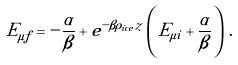Convert formula to latex. <formula><loc_0><loc_0><loc_500><loc_500>E _ { \mu f } = - \frac { \alpha } { \beta } + e ^ { - \beta \rho _ { i c e } z } \left ( E _ { \mu i } + \frac { \alpha } { \beta } \right ) \, .</formula> 